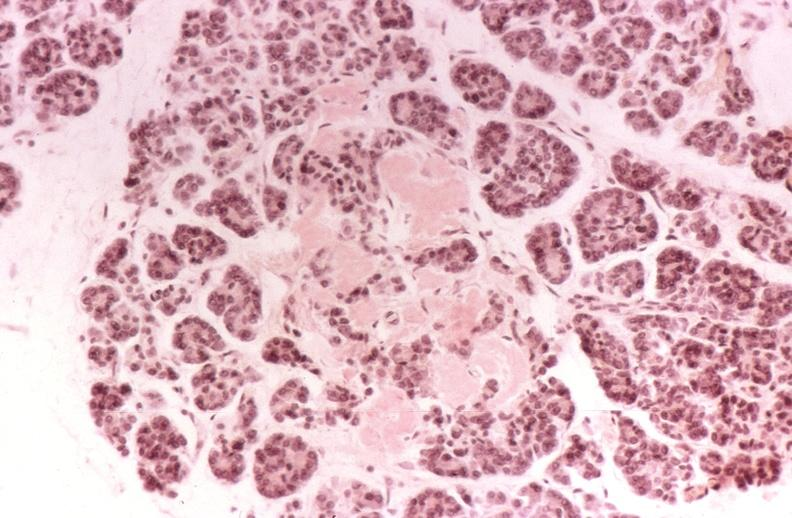s loops present?
Answer the question using a single word or phrase. No 